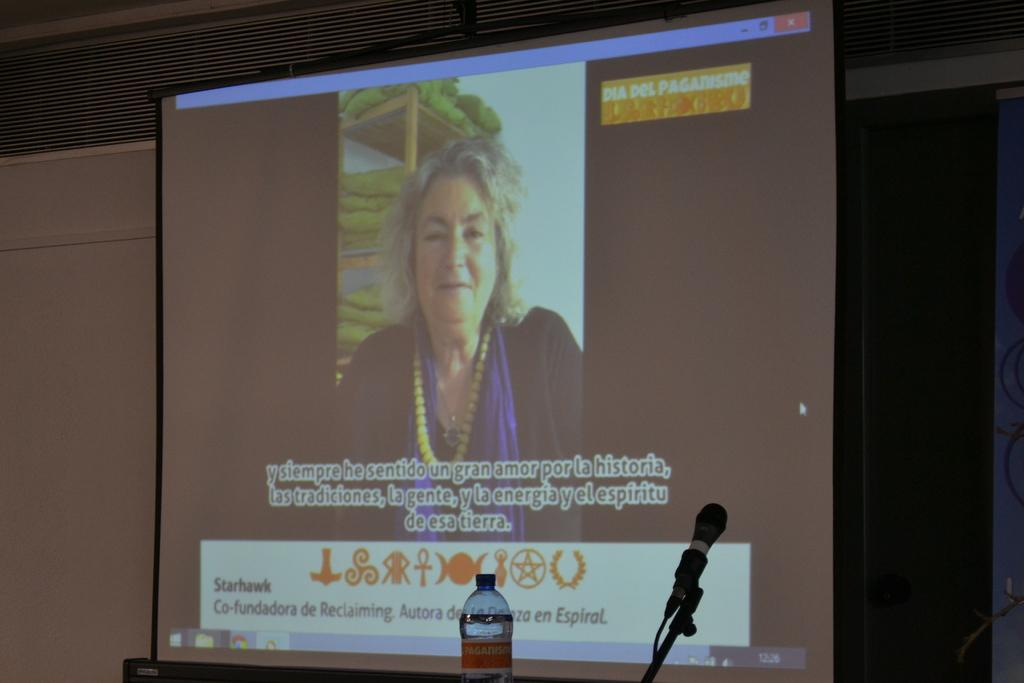What is the main object in the center of the image? A: There is a screen in the center of the image. What objects are located at the bottom of the image? There is a bottle and a microphone (mike) at the bottom of the image. What can be seen in the background of the image? There is a board and other objects visible in the background of the image. What type of mitten is being used to improve health in the image? There is no mitten or reference to health improvement in the image. Is there a tub visible in the image? No, there is no tub present in the image. 